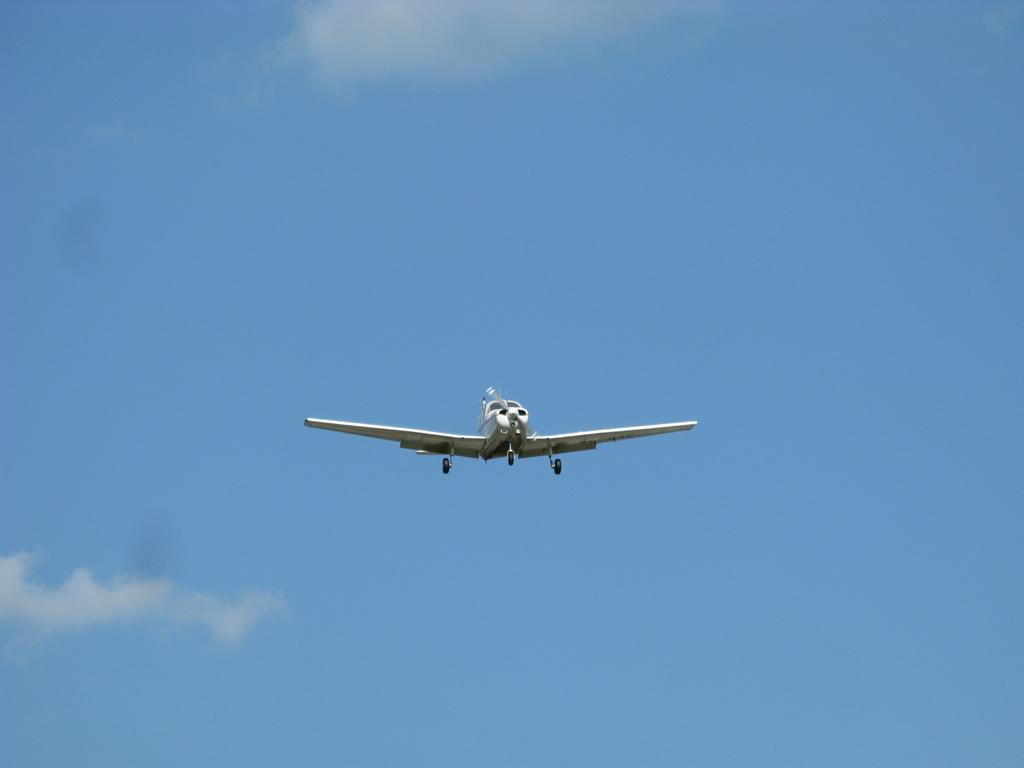What is the main subject of the image? The main subject of the image is an airplane. What is the airplane doing in the image? The airplane is flying in the air. What can be seen in the background of the image? The sky is visible in the background of the image. How would you describe the sky in the image? The sky is a bit cloudy. Can you tell me how many slices of bread are on the airplane in the image? There is no bread present on the airplane in the image. Is there a woman standing next to the airplane in the image? There is no woman visible in the image; it only features an airplane flying in the sky. 